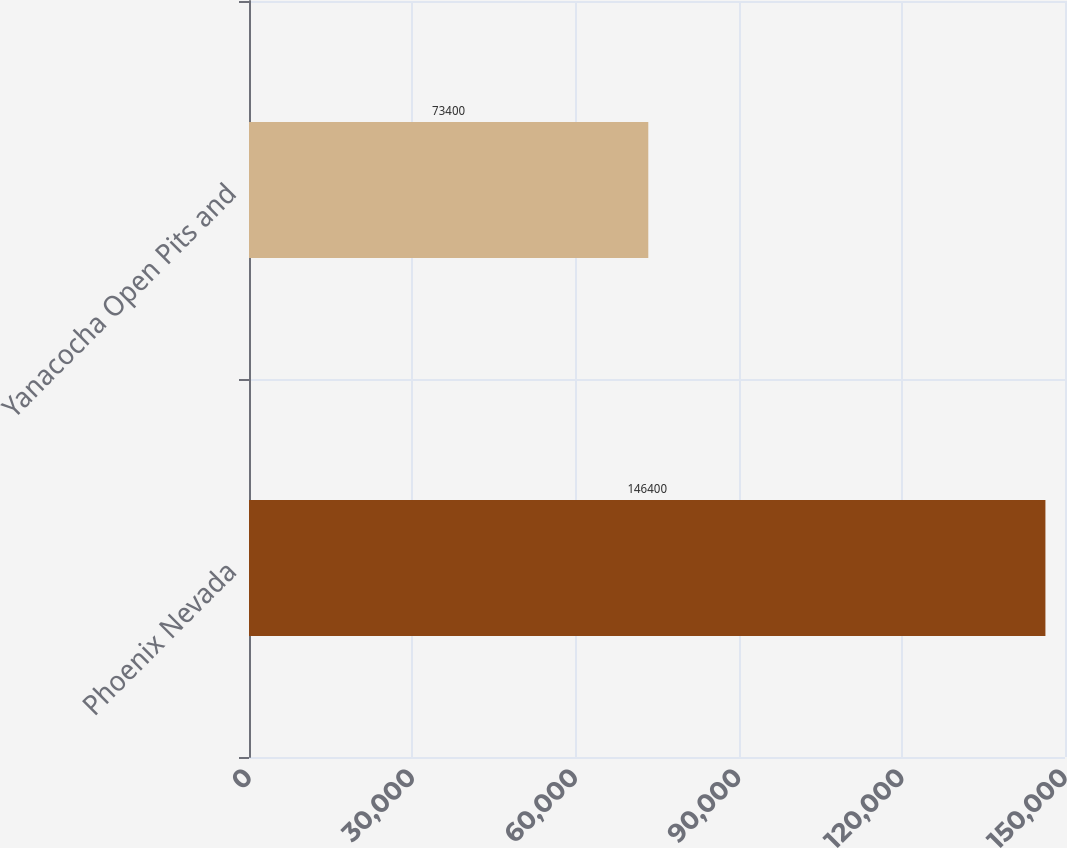<chart> <loc_0><loc_0><loc_500><loc_500><bar_chart><fcel>Phoenix Nevada<fcel>Yanacocha Open Pits and<nl><fcel>146400<fcel>73400<nl></chart> 